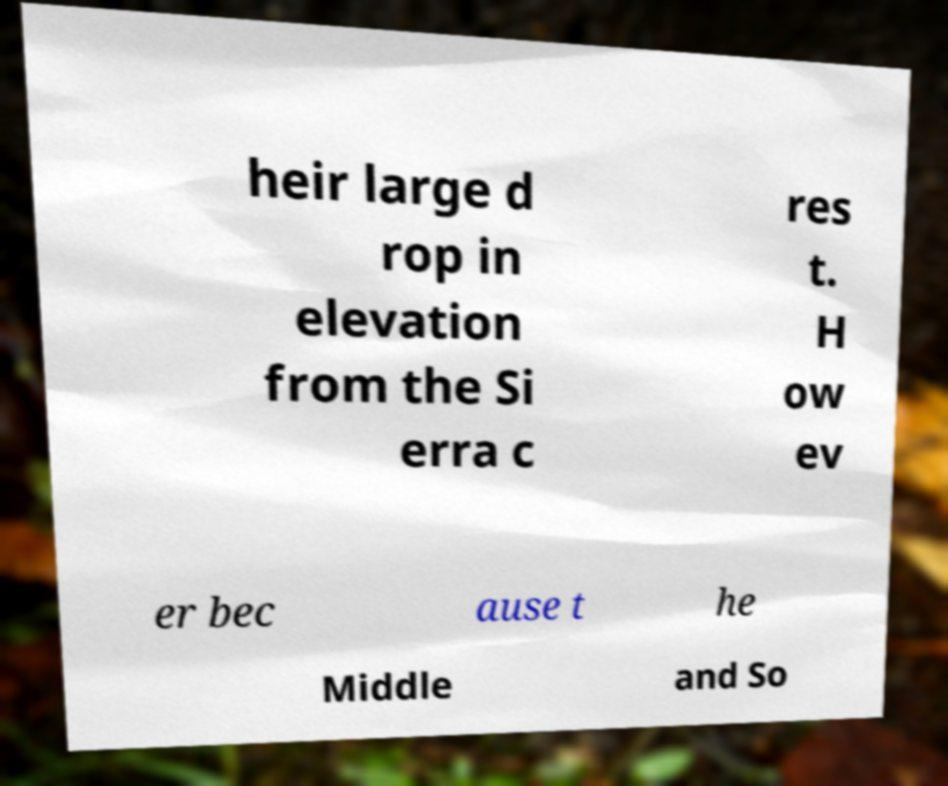What messages or text are displayed in this image? I need them in a readable, typed format. heir large d rop in elevation from the Si erra c res t. H ow ev er bec ause t he Middle and So 